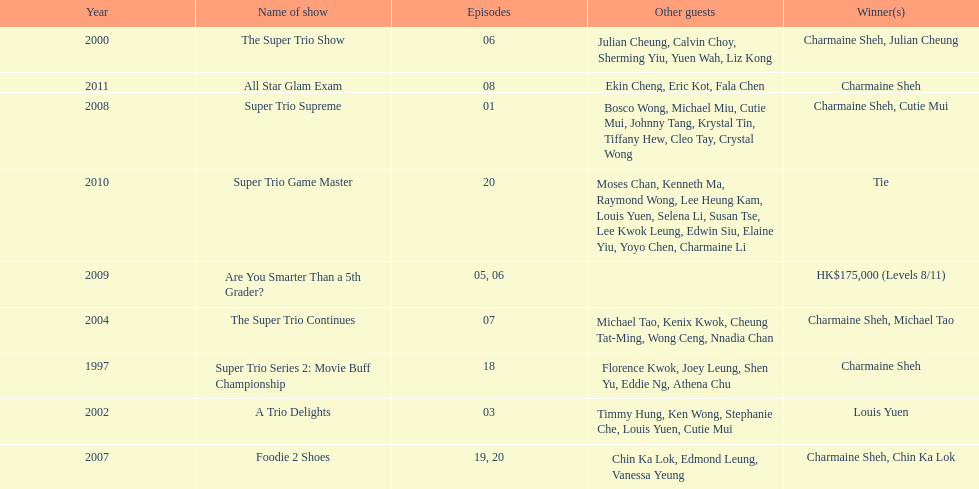How many of shows had at least 5 episodes? 7. 